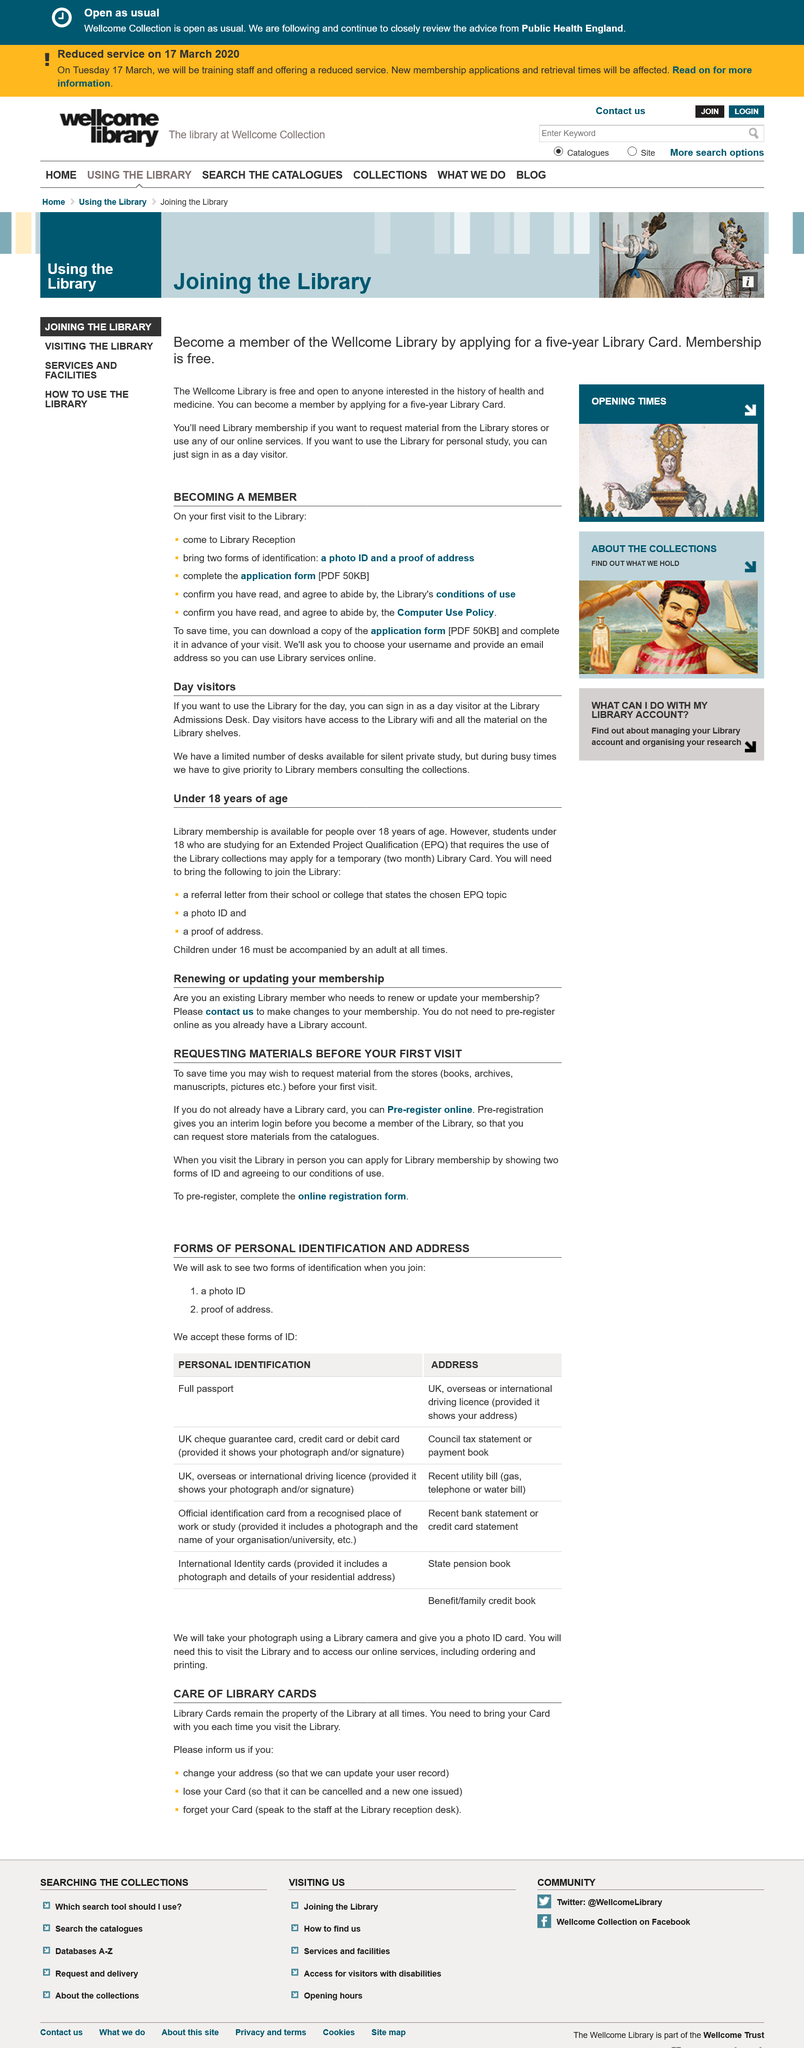Draw attention to some important aspects in this diagram. It is possible to request materials from the stores before your first visit. Day visitors at the library are able to access the library's WiFi and all the materials on the library's shelves. The use of the Library is permissible for day visitors upon signing in at the Library Admissions Desk. It is not necessary to pre-register online if you already have a Library account. The library has a limited number of desks available for private study, but during peak hours, priority is given to members consulting the collections. 